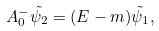<formula> <loc_0><loc_0><loc_500><loc_500>A ^ { - } _ { 0 } \tilde { \psi _ { 2 } } = ( E - m ) \tilde { \psi _ { 1 } } ,</formula> 